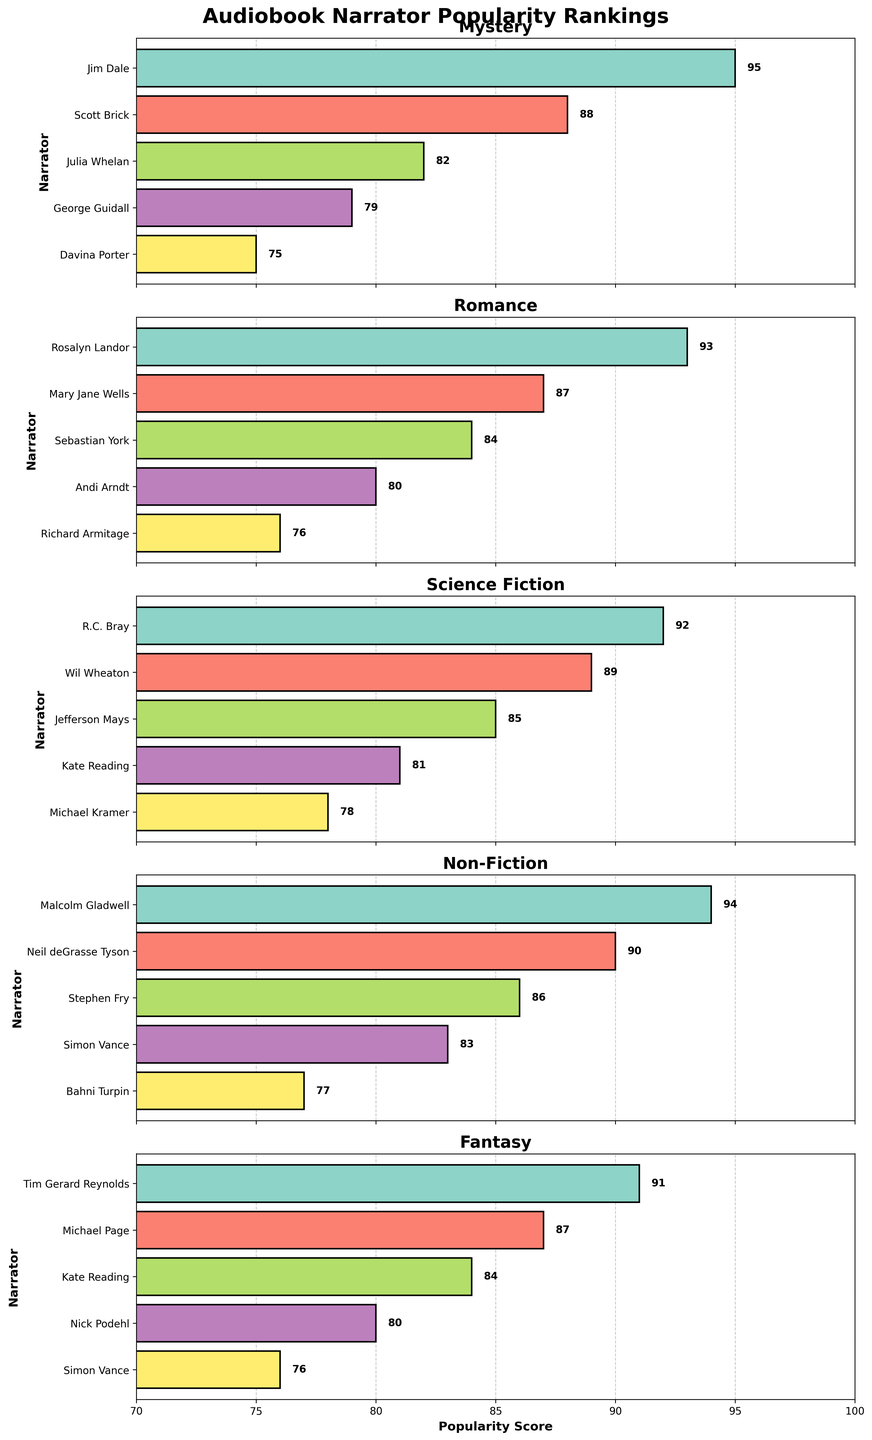Which narrator is the most popular in the Mystery category? The most popular narrator in the Mystery category is the one with the highest popularity score. By looking at the subplot for the Mystery category, Jim Dale has the highest bar with a popularity score of 95.
Answer: Jim Dale Who is the least popular narrator in Romance? The least popular narrator in the Romance category is the one with the lowest popularity score. From the subplot for Romance, we see that Richard Armitage has the lowest bar with a score of 76.
Answer: Richard Armitage Compare the highest popularity scores in Science Fiction and Non-Fiction categories. Which category has a higher score and by how much? The highest popularity score in Science Fiction is 92 (R.C. Bray) and in Non-Fiction is 94 (Malcolm Gladwell). Non-Fiction has a higher score. The difference is 94 - 92 = 2.
Answer: Non-Fiction by 2 What is the average popularity score of the narrators in the Fantasy category? To compute the average, sum up the popularity scores of narrators in the Fantasy category and divide by the number of narrators. The scores are 91, 87, 84, 80, and 76. Sum = 91 + 87 + 84 + 80 + 76 = 418. There are 5 narrators. So, the average is 418 / 5 = 83.6.
Answer: 83.6 Which narrator has the highest popularity score in all the categories? To find the narrator with the highest popularity score across all categories, we look for the tallest bar across all subplots. Jim Dale in the Mystery category has the highest score of 95.
Answer: Jim Dale Which category has the closest range of popularity scores? To find the category with the closest range, we calculate the difference between the maximum and minimum scores in each category. Mystery: 95 - 75 = 20. Romance: 93 - 76 = 17. Science Fiction: 92 - 78 = 14. Non-Fiction: 94 - 77 = 17. Fantasy: 91 - 76 = 15. Science Fiction has the closest range of 14.
Answer: Science Fiction If Kate Reading narrates both Science Fiction and Fantasy, what is her average popularity score? Kate Reading has scores of 81 in Science Fiction and 84 in Fantasy. Adding these scores: 81 + 84 = 165. There are 2 scores, so the average is 165 / 2 = 82.5.
Answer: 82.5 What is the combined popularity score of the top three narrators in the Romance category? To find the combined score, sum the popularity scores of the top three narrators in the Romance category. They are Rosalyn Landor (93), Mary Jane Wells (87), and Sebastian York (84). Sum = 93 + 87 + 84 = 264.
Answer: 264 